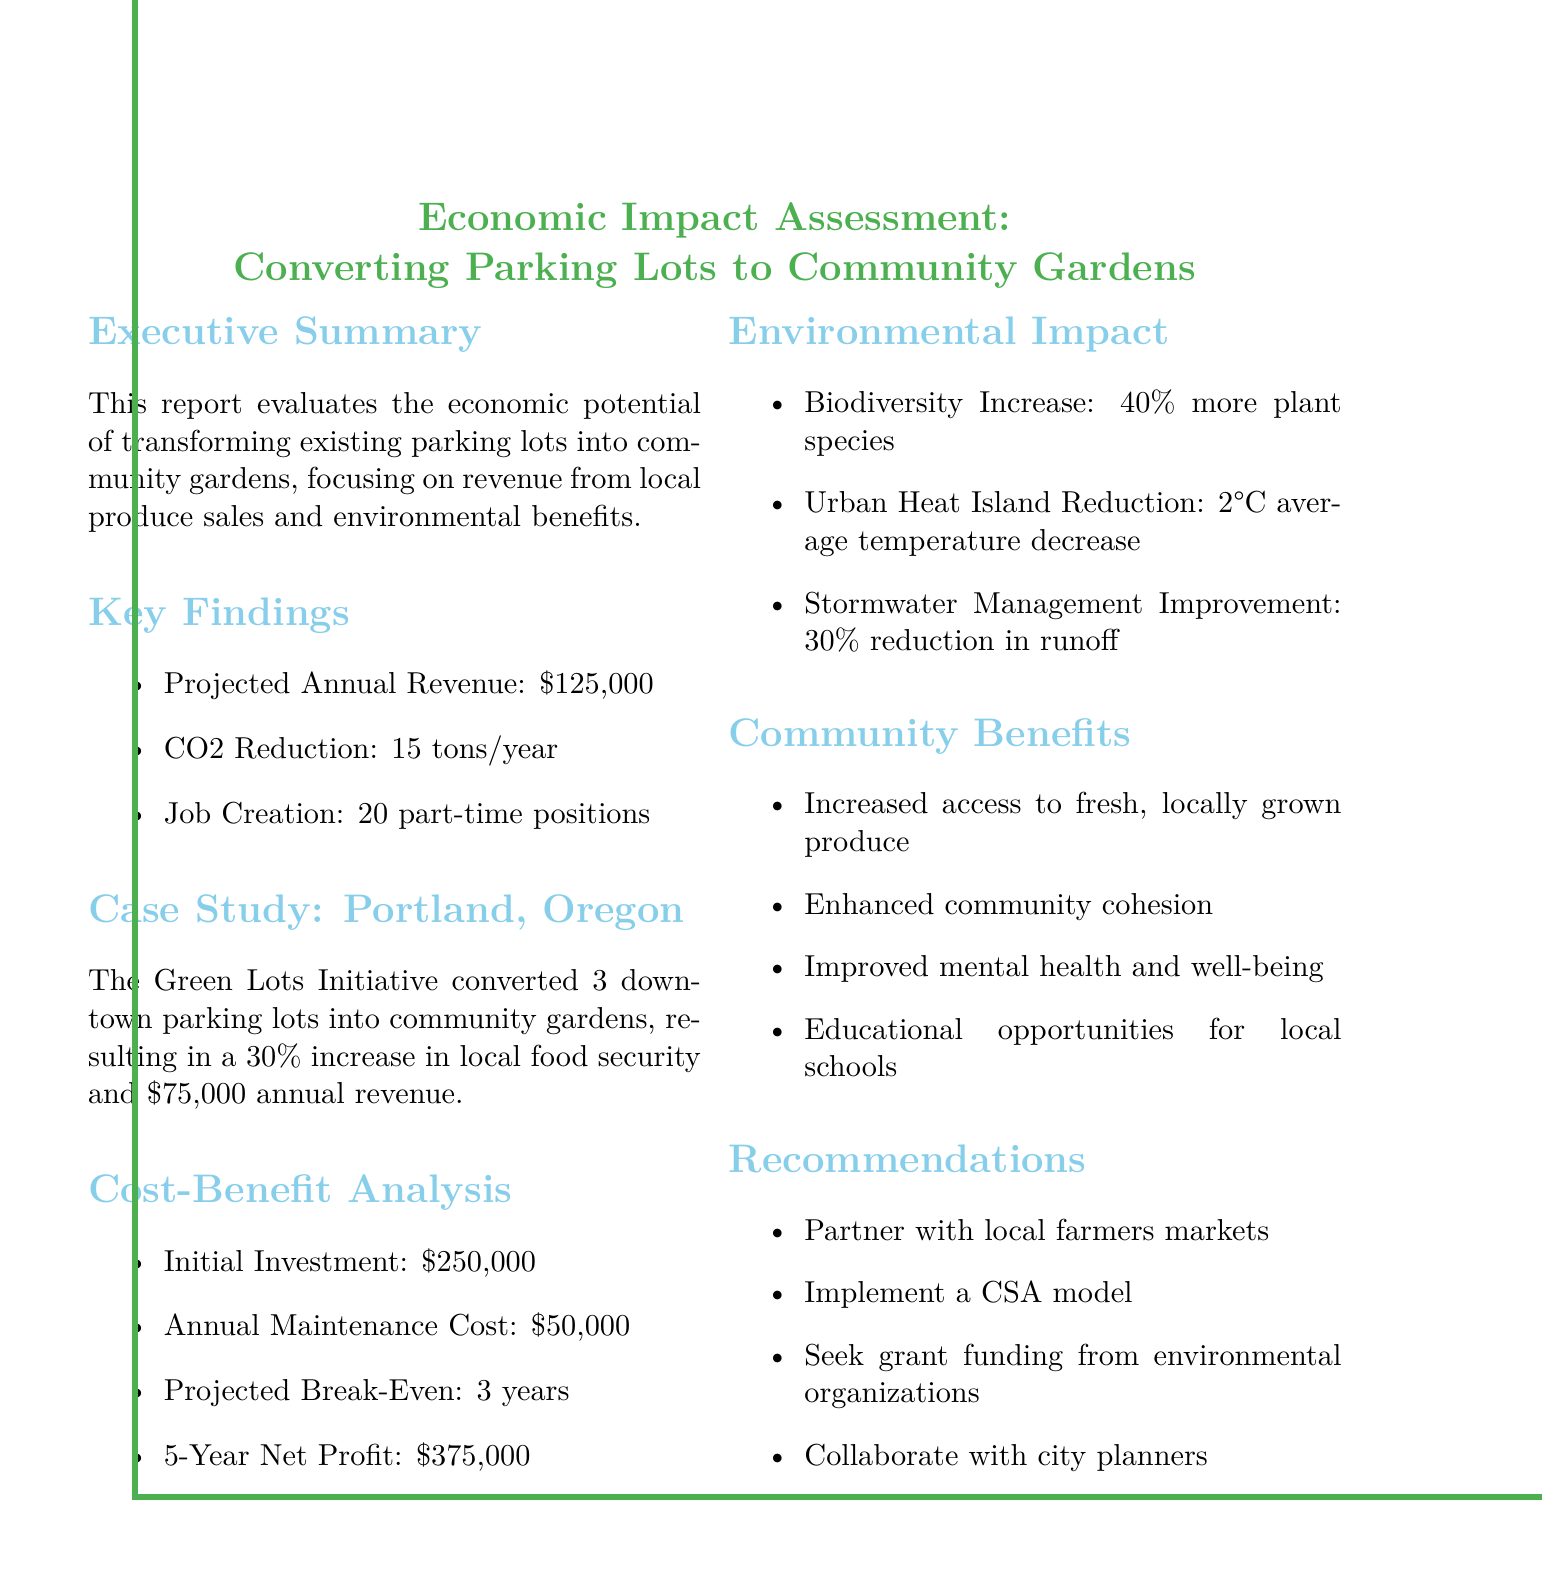What is the projected annual revenue? The projected annual revenue is stated explicitly in the key findings section of the document, which is $125,000.
Answer: $125,000 What is the initial investment required? The initial investment required is mentioned in the cost-benefit analysis section of the document, which is $250,000.
Answer: $250,000 How many part-time positions will be created? The number of part-time positions created is detailed in the key findings of the document, which states 20 part-time positions.
Answer: 20 part-time positions What is the reduction in CO2 emissions per year? The reduction in CO2 emissions per year is specified in the key findings section, which indicates a reduction of 15 tons/year.
Answer: 15 tons/year What percentage increase in local food security resulted from the case study? The percentage increase in local food security is found in the case study section, which reports a 30% increase in local food security.
Answer: 30% What is the expected time to break-even? The expected time to break-even is mentioned in the cost-benefit analysis, which specifies a break-even time of 3 years.
Answer: 3 years How much is the projected net profit after 5 years? The projected net profit after 5 years is detailed in the cost-benefit analysis section, which mentions a net profit of $375,000.
Answer: $375,000 What environmental benefit has increased by 40%? The environmental benefit that has increased by 40% is specified in the environmental impact section, referring to plant species.
Answer: Plant species What models are recommended for produce distribution? The models recommended for produce distribution are suggested in the recommendations section, including a community-supported agriculture (CSA) model.
Answer: CSA model 